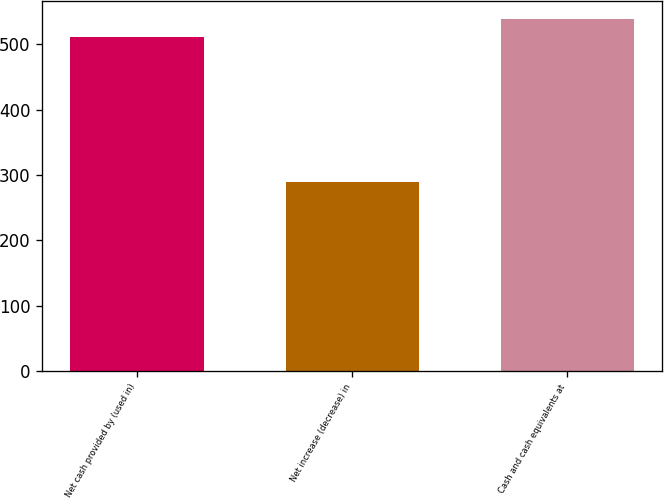Convert chart to OTSL. <chart><loc_0><loc_0><loc_500><loc_500><bar_chart><fcel>Net cash provided by (used in)<fcel>Net increase (decrease) in<fcel>Cash and cash equivalents at<nl><fcel>511.2<fcel>288.63<fcel>538.73<nl></chart> 